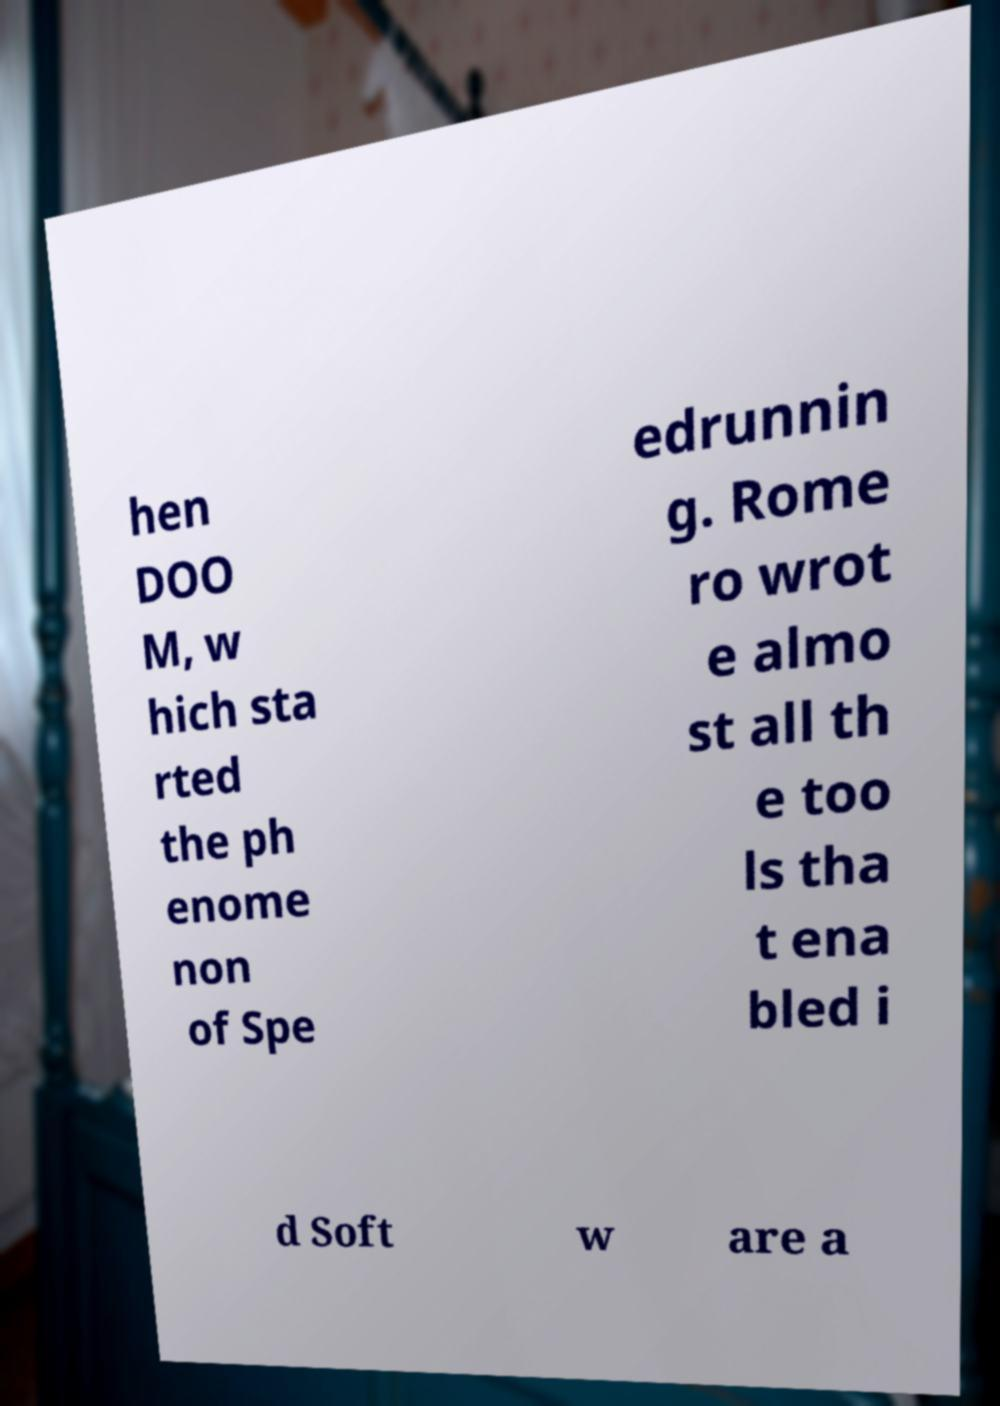Please read and relay the text visible in this image. What does it say? hen DOO M, w hich sta rted the ph enome non of Spe edrunnin g. Rome ro wrot e almo st all th e too ls tha t ena bled i d Soft w are a 